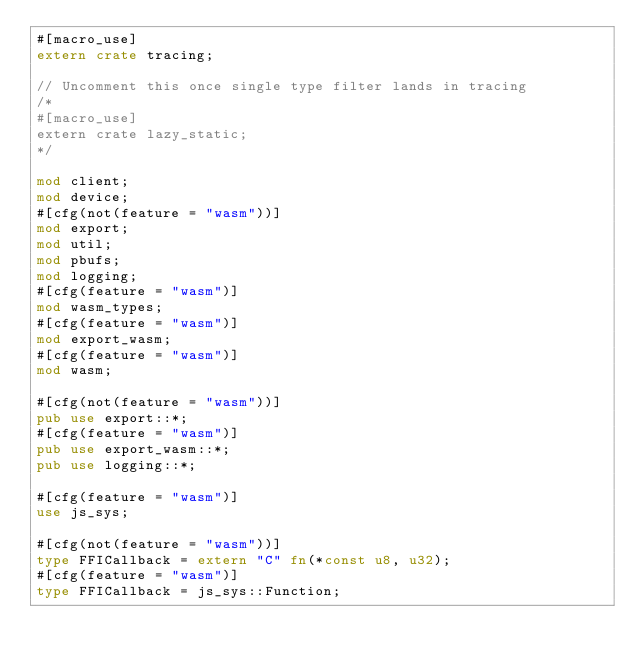Convert code to text. <code><loc_0><loc_0><loc_500><loc_500><_Rust_>#[macro_use]
extern crate tracing;

// Uncomment this once single type filter lands in tracing
/*
#[macro_use]
extern crate lazy_static;
*/

mod client;
mod device;
#[cfg(not(feature = "wasm"))]
mod export;
mod util;
mod pbufs;
mod logging;
#[cfg(feature = "wasm")]
mod wasm_types;
#[cfg(feature = "wasm")]
mod export_wasm;
#[cfg(feature = "wasm")]
mod wasm;

#[cfg(not(feature = "wasm"))]
pub use export::*;
#[cfg(feature = "wasm")]
pub use export_wasm::*;
pub use logging::*;

#[cfg(feature = "wasm")]
use js_sys;

#[cfg(not(feature = "wasm"))]
type FFICallback = extern "C" fn(*const u8, u32);
#[cfg(feature = "wasm")]
type FFICallback = js_sys::Function;
</code> 